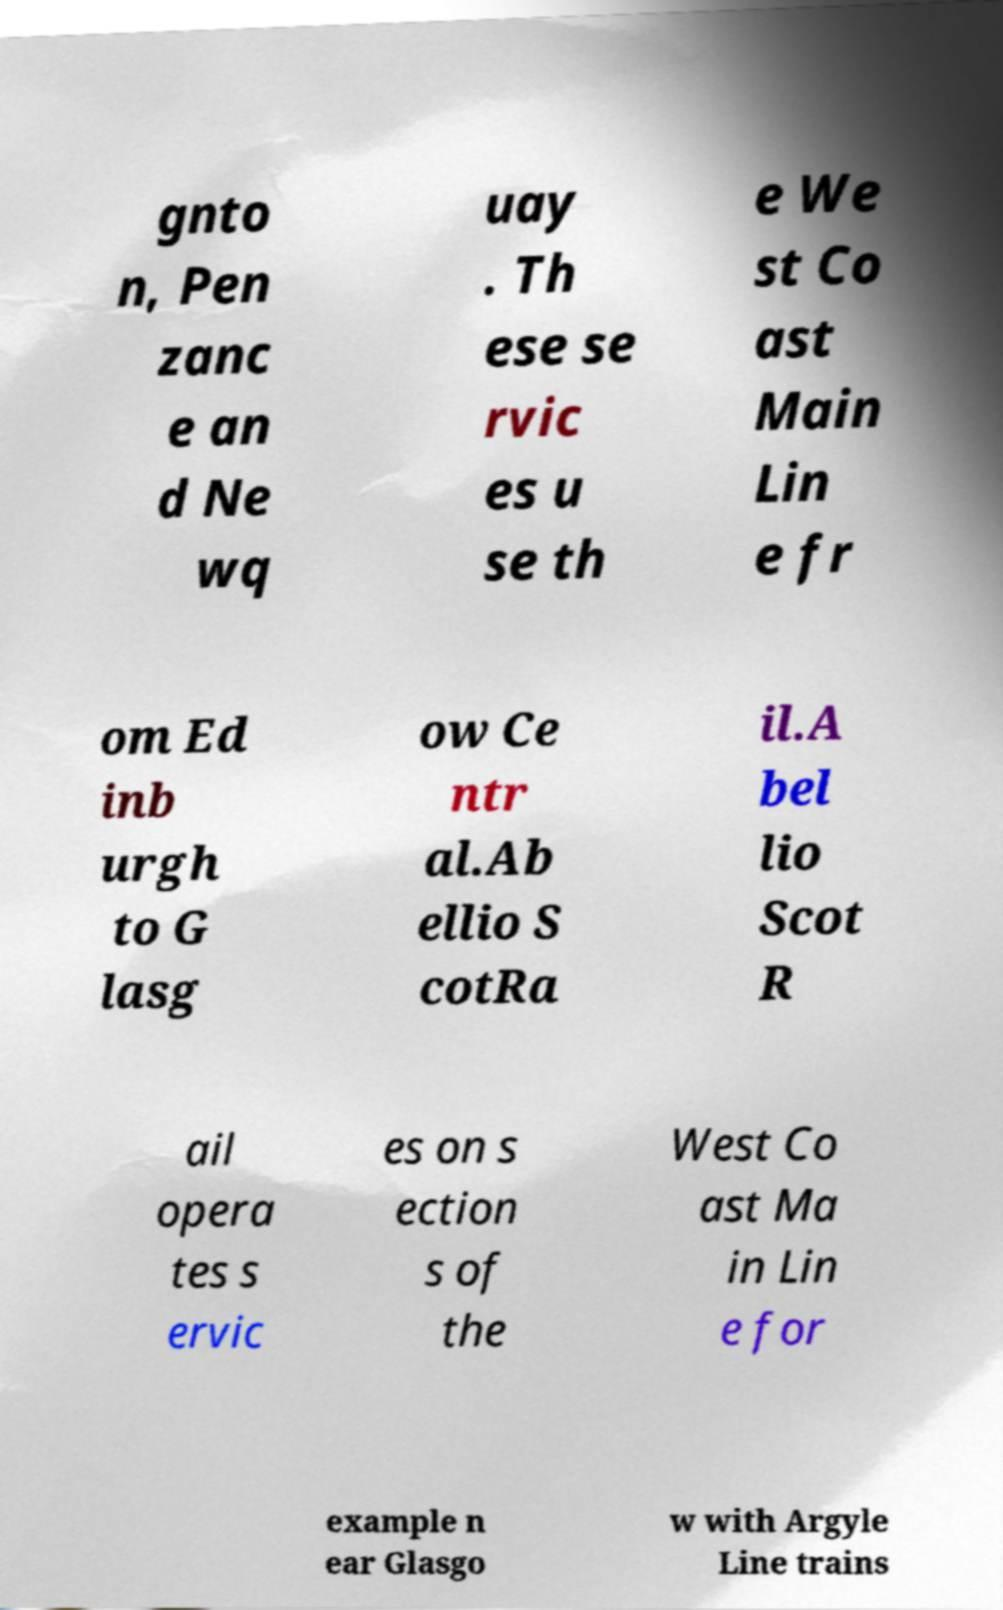Could you assist in decoding the text presented in this image and type it out clearly? gnto n, Pen zanc e an d Ne wq uay . Th ese se rvic es u se th e We st Co ast Main Lin e fr om Ed inb urgh to G lasg ow Ce ntr al.Ab ellio S cotRa il.A bel lio Scot R ail opera tes s ervic es on s ection s of the West Co ast Ma in Lin e for example n ear Glasgo w with Argyle Line trains 